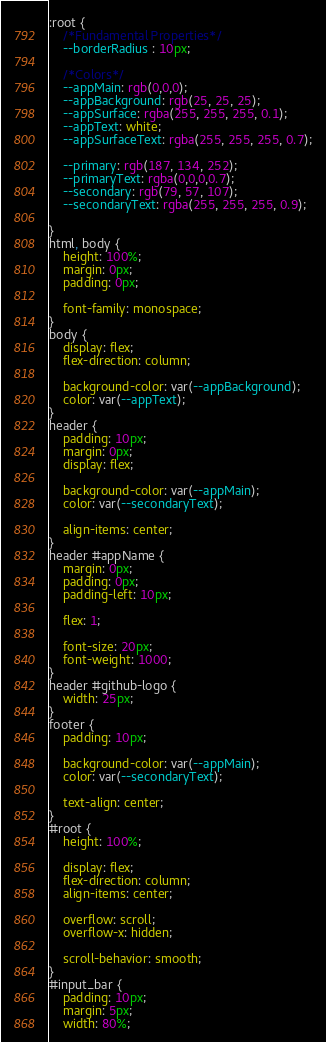Convert code to text. <code><loc_0><loc_0><loc_500><loc_500><_CSS_>:root {
    /*Fundamental Properties*/
    --borderRadius : 10px;

    /*Colors*/
    --appMain: rgb(0,0,0);
    --appBackground: rgb(25, 25, 25);
    --appSurface: rgba(255, 255, 255, 0.1);
    --appText: white;
    --appSurfaceText: rgba(255, 255, 255, 0.7);

    --primary: rgb(187, 134, 252);
    --primaryText: rgba(0,0,0,0.7);
    --secondary: rgb(79, 57, 107);
    --secondaryText: rgba(255, 255, 255, 0.9);

}
html, body {
    height: 100%;
    margin: 0px;
    padding: 0px;

    font-family: monospace;
}
body {
    display: flex;
    flex-direction: column;

    background-color: var(--appBackground);
    color: var(--appText);
}
header {
    padding: 10px;
    margin: 0px;
    display: flex;

    background-color: var(--appMain);
    color: var(--secondaryText);

    align-items: center;
}
header #appName {
    margin: 0px;
    padding: 0px;
    padding-left: 10px;

    flex: 1;

    font-size: 20px;
    font-weight: 1000;
}
header #github-logo {
    width: 25px;
}
footer {
    padding: 10px;

    background-color: var(--appMain);
    color: var(--secondaryText);

    text-align: center;
}
#root {
    height: 100%;

    display: flex;
    flex-direction: column;
    align-items: center;

    overflow: scroll;
    overflow-x: hidden;

    scroll-behavior: smooth;
}
#input_bar {
    padding: 10px;
    margin: 5px;
    width: 80%;</code> 